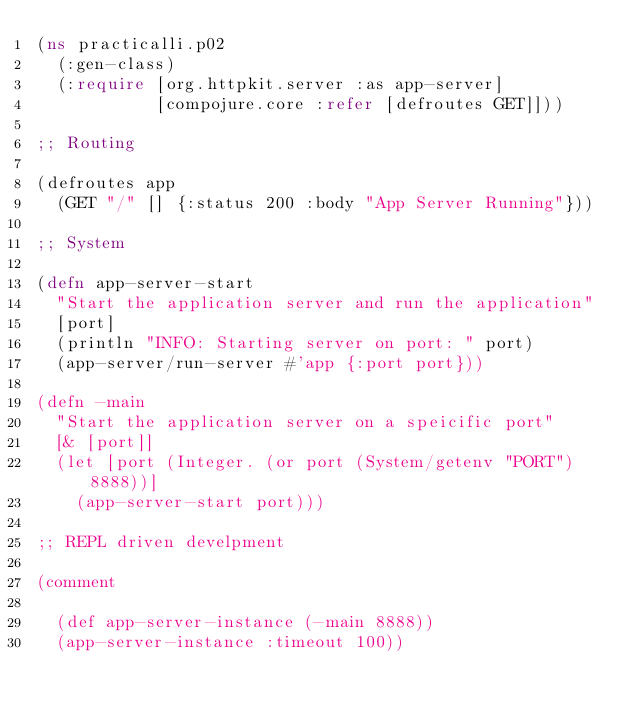<code> <loc_0><loc_0><loc_500><loc_500><_Clojure_>(ns practicalli.p02
  (:gen-class)
  (:require [org.httpkit.server :as app-server]
            [compojure.core :refer [defroutes GET]]))

;; Routing

(defroutes app
  (GET "/" [] {:status 200 :body "App Server Running"}))

;; System

(defn app-server-start
  "Start the application server and run the application"
  [port]
  (println "INFO: Starting server on port: " port)
  (app-server/run-server #'app {:port port}))

(defn -main
  "Start the application server on a speicific port"
  [& [port]]
  (let [port (Integer. (or port (System/getenv "PORT") 8888))]
    (app-server-start port)))

;; REPL driven develpment

(comment

  (def app-server-instance (-main 8888))
  (app-server-instance :timeout 100))

</code> 